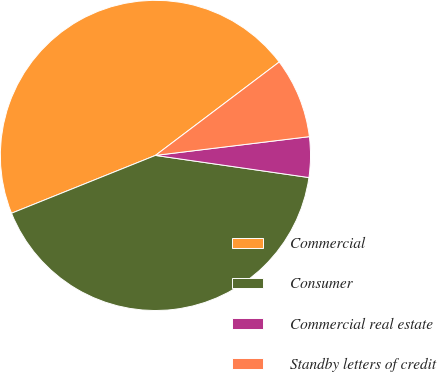Convert chart to OTSL. <chart><loc_0><loc_0><loc_500><loc_500><pie_chart><fcel>Commercial<fcel>Consumer<fcel>Commercial real estate<fcel>Standby letters of credit<nl><fcel>45.79%<fcel>41.64%<fcel>4.21%<fcel>8.36%<nl></chart> 